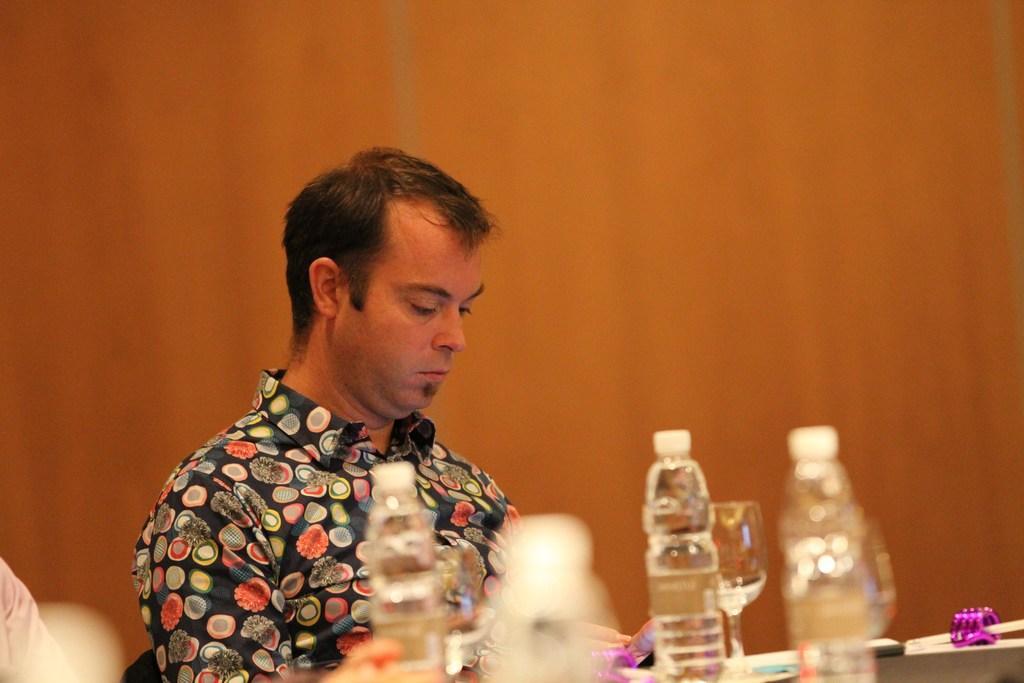Can you describe this image briefly? In this image i can see a person siting in front of a table on the table i can see few water bottles and a glass. 